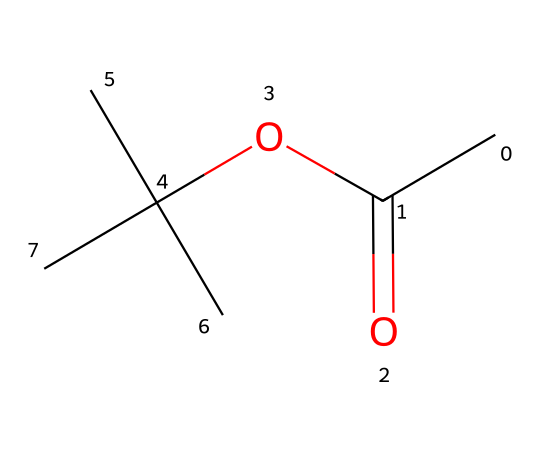What is the molecular formula of this compound? To find the molecular formula, count the number of carbon (C), hydrogen (H), and oxygen (O) atoms in the chemical structure. The structure has 5 carbon atoms, 10 hydrogen atoms, and 2 oxygen atoms, giving the formula C5H10O2.
Answer: C5H10O2 How many stereocenters are present in this molecule? A stereocenter is typically a carbon atom bonded to four different groups. In the structure provided, there is one carbon atom at the branching point that is connected to three distinct groups. Therefore, this molecule has one stereocenter.
Answer: 1 What type of functional group is present in this compound? Look for distinctive groupings of atoms that define the chemical's characteristics. The structure shows an ester functional group, which is characterized by the -COO- portion.
Answer: ester Does this compound have an aroma? Esters are known for their fragrant odors, combining different characteristics that contribute to a pleasant smell. Thus, as an ester, this compound typically has an aroma.
Answer: yes What is the degree of unsaturation in this molecule? To find the degree of unsaturation, use the formula: (2C + 2 + N - H - X) / 2. In this case, C=5, H=10, and there are no nitrogen or halogen atoms, resulting in a degree of unsaturation of 0, indicating no double bonds or rings.
Answer: 0 